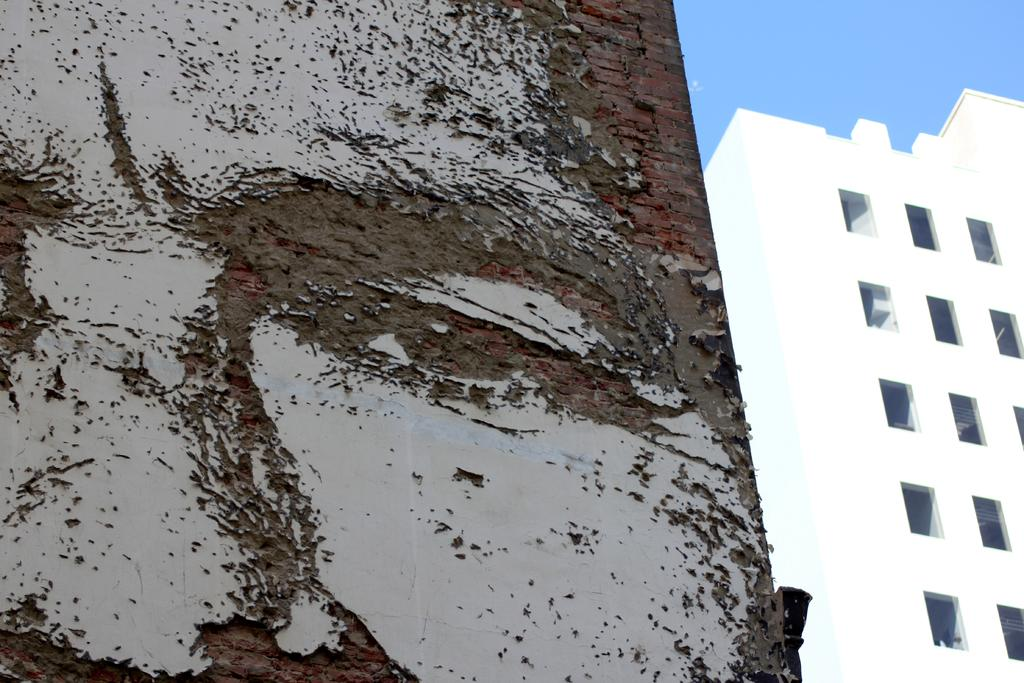What type of structures can be seen in the image? There are buildings in the image. What else can be seen besides the buildings? There is a wall in the image. What part of the natural environment is visible in the image? The sky is visible in the image. What type of trees are present in the image? There are no trees visible in the image; only buildings, a wall, and the sky are present. 